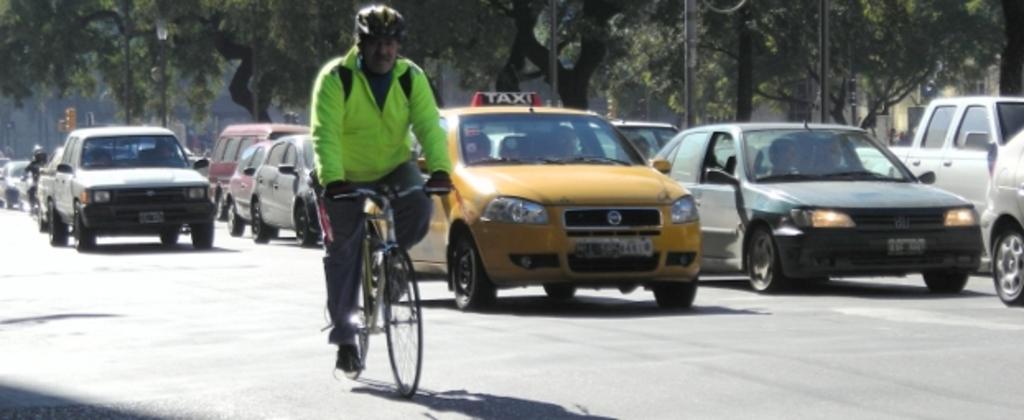What does the yellow car say on top?
Offer a very short reply. Taxi. 